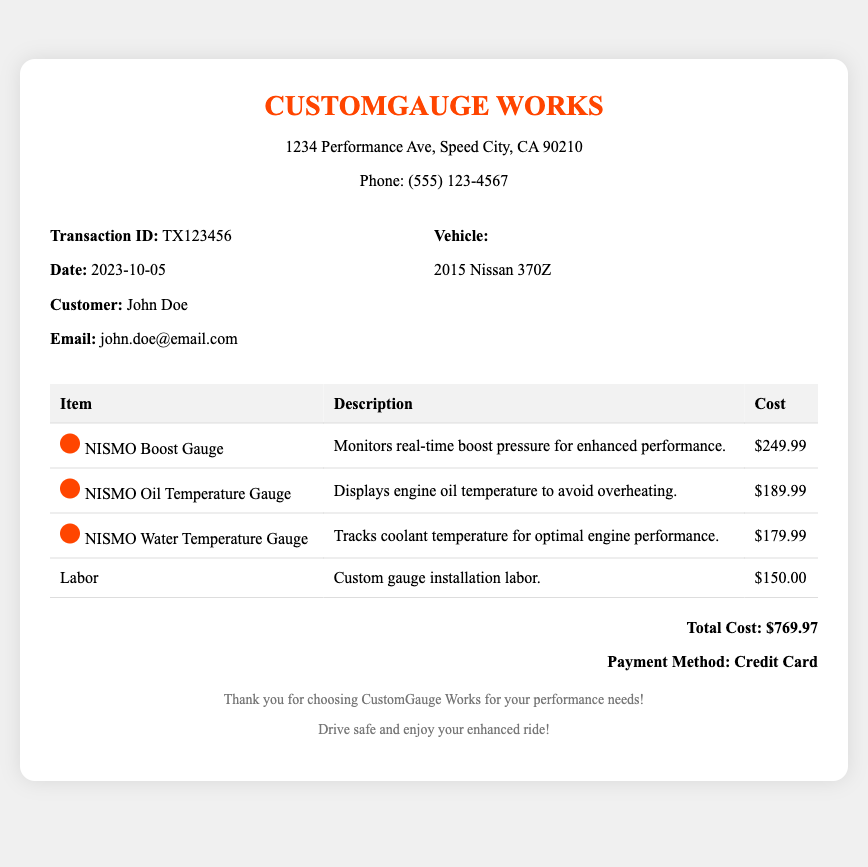What is the transaction ID? The transaction ID is a unique identifier for this receipt, which is specified as TX123456.
Answer: TX123456 What is the date of the service? The date of the service is stated in the receipt, which is 2023-10-05.
Answer: 2023-10-05 Who is the customer? The name of the customer is provided in the document, which is John Doe.
Answer: John Doe What vehicle model is mentioned? The vehicle model being serviced is listed as 2015 Nissan 370Z.
Answer: 2015 Nissan 370Z What is the cost of the NISMO Boost Gauge? The document specifies the cost for the NISMO Boost Gauge, which is $249.99.
Answer: $249.99 What is the total cost for the installation? The total cost is presented at the end of the receipt, totaling $769.97.
Answer: $769.97 How much was charged for labor? The labor cost for the custom gauge installation is explicitly mentioned as $150.00.
Answer: $150.00 Which payment method was used? The payment method used for the transaction is outlined in the receipt as Credit Card.
Answer: Credit Card 